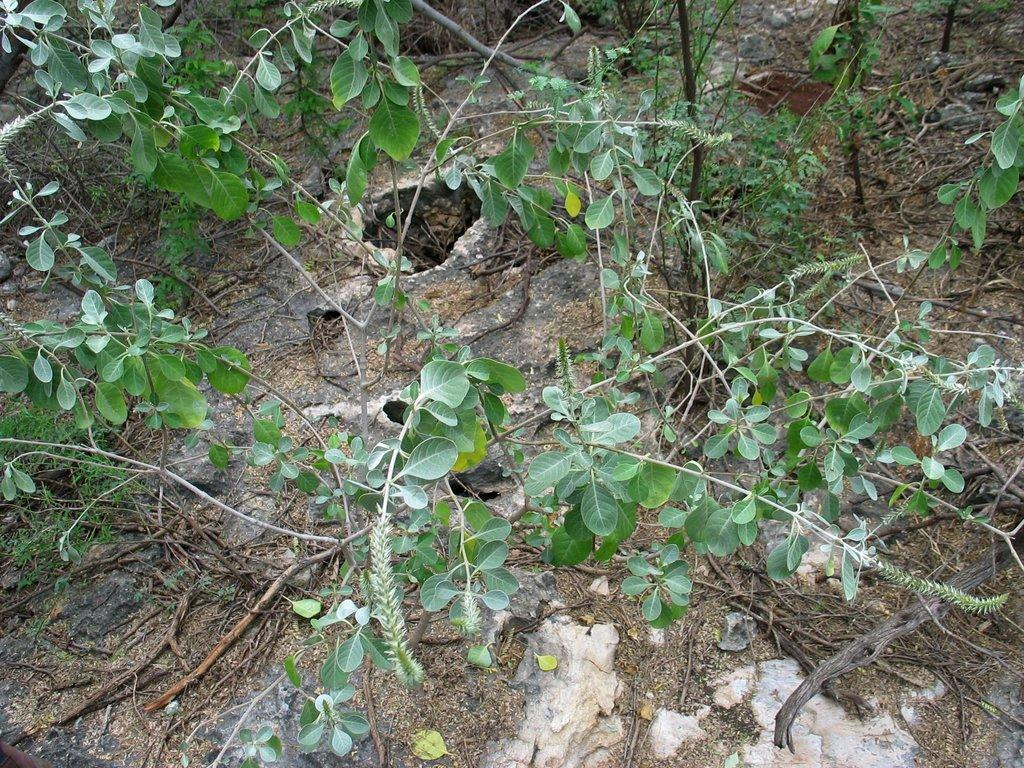What type of living organisms can be seen in the image? Plants can be seen in the image. What can be found at the bottom of the image? There are sticks and dust at the bottom of the image. Where are the green leaves located in the image? The green leaves are on the left side of the image. What type of toys can be seen in the hands of the person in the image? There is no person or toys present in the image; it only features plants, sticks, dust, and green leaves. 